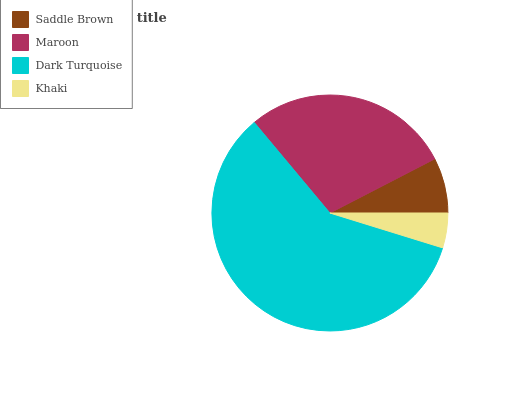Is Khaki the minimum?
Answer yes or no. Yes. Is Dark Turquoise the maximum?
Answer yes or no. Yes. Is Maroon the minimum?
Answer yes or no. No. Is Maroon the maximum?
Answer yes or no. No. Is Maroon greater than Saddle Brown?
Answer yes or no. Yes. Is Saddle Brown less than Maroon?
Answer yes or no. Yes. Is Saddle Brown greater than Maroon?
Answer yes or no. No. Is Maroon less than Saddle Brown?
Answer yes or no. No. Is Maroon the high median?
Answer yes or no. Yes. Is Saddle Brown the low median?
Answer yes or no. Yes. Is Dark Turquoise the high median?
Answer yes or no. No. Is Khaki the low median?
Answer yes or no. No. 